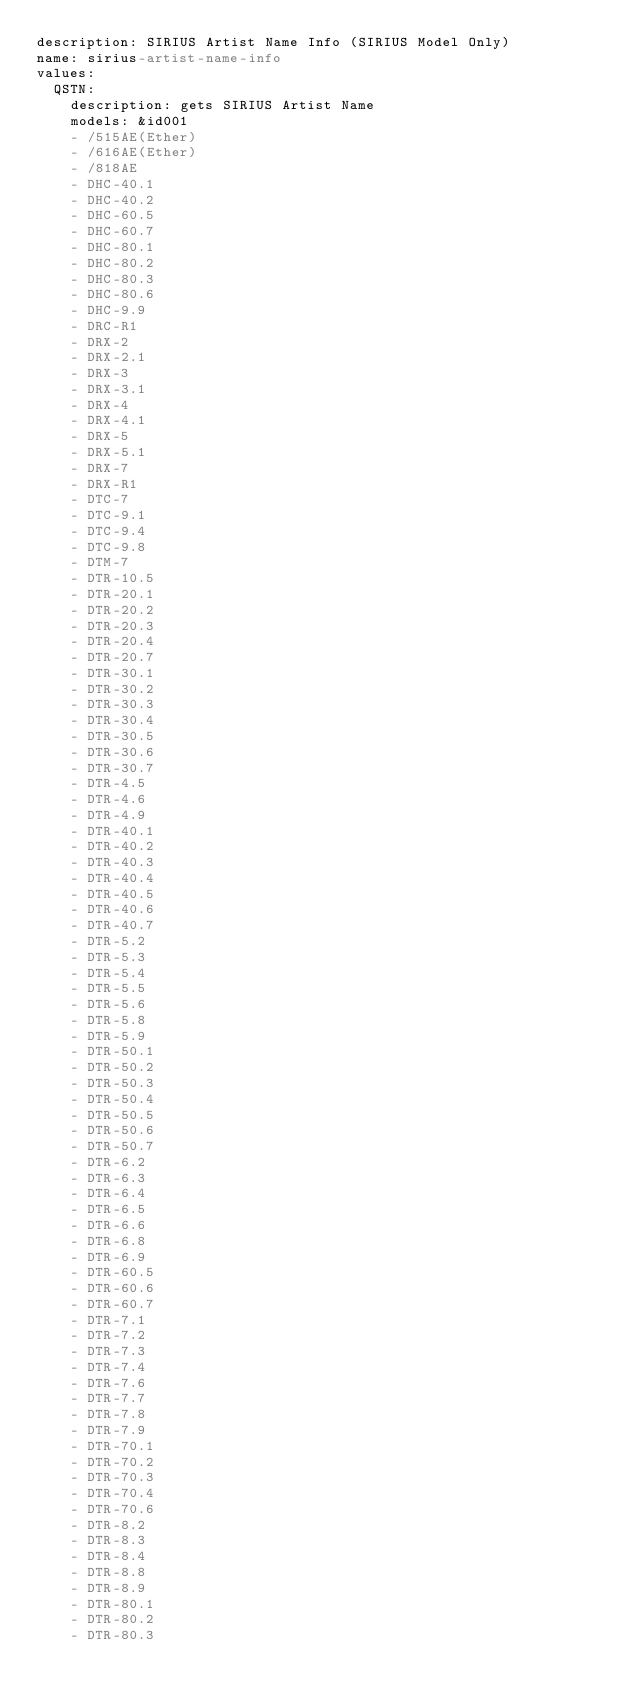Convert code to text. <code><loc_0><loc_0><loc_500><loc_500><_YAML_>description: SIRIUS Artist Name Info (SIRIUS Model Only)
name: sirius-artist-name-info
values:
  QSTN:
    description: gets SIRIUS Artist Name
    models: &id001
    - /515AE(Ether)
    - /616AE(Ether)
    - /818AE
    - DHC-40.1
    - DHC-40.2
    - DHC-60.5
    - DHC-60.7
    - DHC-80.1
    - DHC-80.2
    - DHC-80.3
    - DHC-80.6
    - DHC-9.9
    - DRC-R1
    - DRX-2
    - DRX-2.1
    - DRX-3
    - DRX-3.1
    - DRX-4
    - DRX-4.1
    - DRX-5
    - DRX-5.1
    - DRX-7
    - DRX-R1
    - DTC-7
    - DTC-9.1
    - DTC-9.4
    - DTC-9.8
    - DTM-7
    - DTR-10.5
    - DTR-20.1
    - DTR-20.2
    - DTR-20.3
    - DTR-20.4
    - DTR-20.7
    - DTR-30.1
    - DTR-30.2
    - DTR-30.3
    - DTR-30.4
    - DTR-30.5
    - DTR-30.6
    - DTR-30.7
    - DTR-4.5
    - DTR-4.6
    - DTR-4.9
    - DTR-40.1
    - DTR-40.2
    - DTR-40.3
    - DTR-40.4
    - DTR-40.5
    - DTR-40.6
    - DTR-40.7
    - DTR-5.2
    - DTR-5.3
    - DTR-5.4
    - DTR-5.5
    - DTR-5.6
    - DTR-5.8
    - DTR-5.9
    - DTR-50.1
    - DTR-50.2
    - DTR-50.3
    - DTR-50.4
    - DTR-50.5
    - DTR-50.6
    - DTR-50.7
    - DTR-6.2
    - DTR-6.3
    - DTR-6.4
    - DTR-6.5
    - DTR-6.6
    - DTR-6.8
    - DTR-6.9
    - DTR-60.5
    - DTR-60.6
    - DTR-60.7
    - DTR-7.1
    - DTR-7.2
    - DTR-7.3
    - DTR-7.4
    - DTR-7.6
    - DTR-7.7
    - DTR-7.8
    - DTR-7.9
    - DTR-70.1
    - DTR-70.2
    - DTR-70.3
    - DTR-70.4
    - DTR-70.6
    - DTR-8.2
    - DTR-8.3
    - DTR-8.4
    - DTR-8.8
    - DTR-8.9
    - DTR-80.1
    - DTR-80.2
    - DTR-80.3</code> 